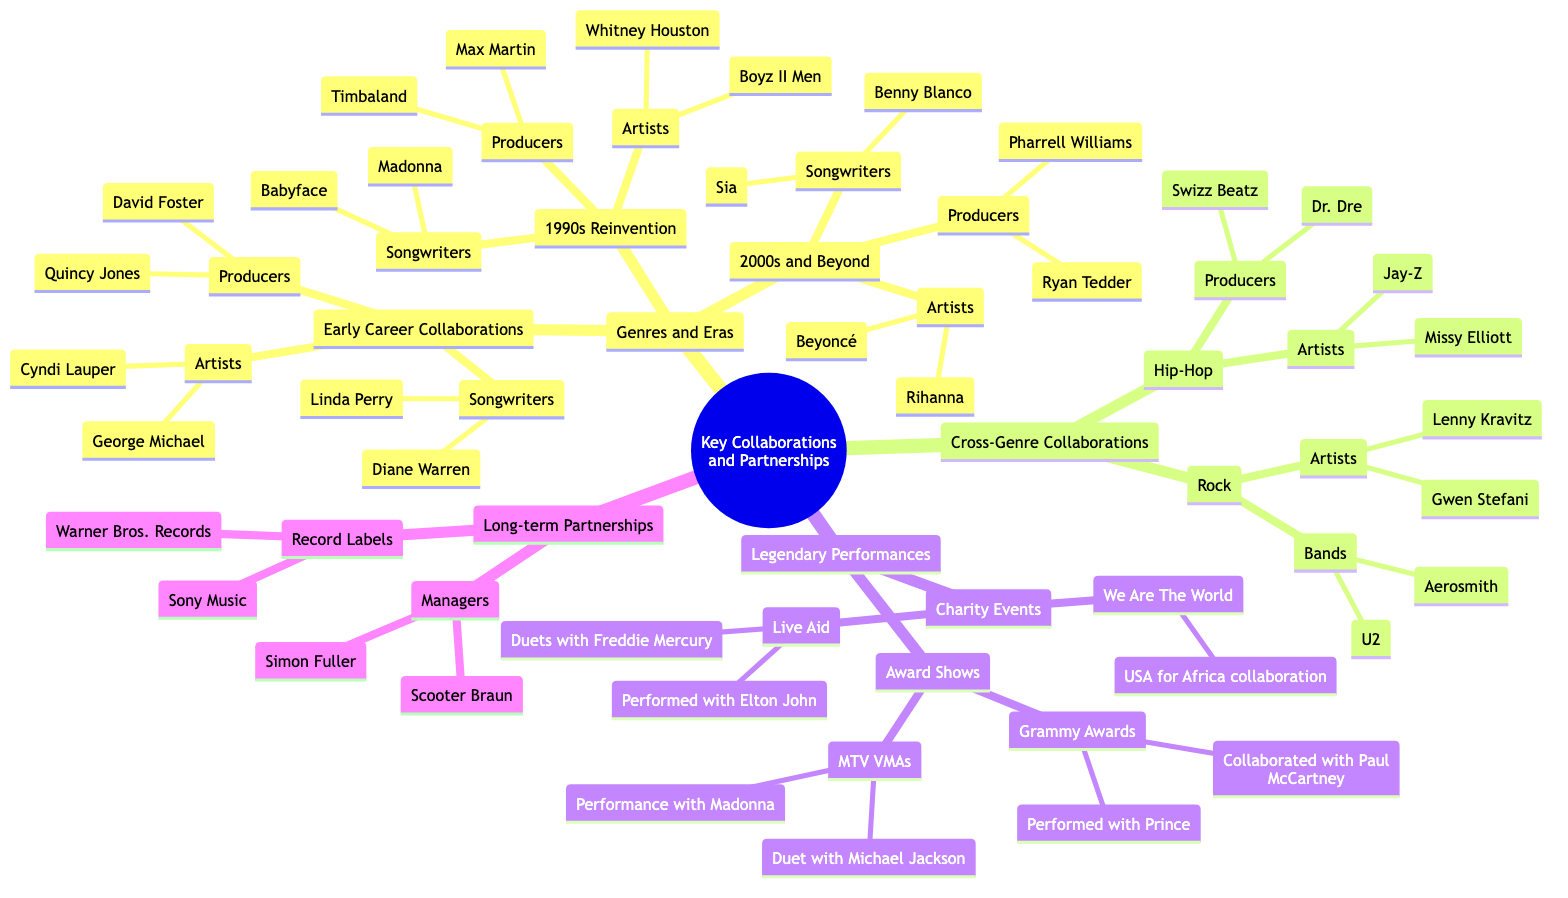What are the names of two producers from my early career collaborations? The diagram lists two producers under the "Early Career Collaborations" node: Quincy Jones and David Foster.
Answer: Quincy Jones, David Foster Who are the songwriters I collaborated with in the 1990s? The 1990s Reinvention section shows two songwriters: Babyface and Madonna.
Answer: Babyface, Madonna How many artists are listed under the "2000s and Beyond"? In the "2000s and Beyond" section, there are two artists mentioned: Beyoncé and Rihanna. Therefore, the total number of artists is two.
Answer: 2 Which event includes "USA for Africa collaboration"? The "We Are The World" node under "Legendary Performances" directs to the USA for Africa collaboration.
Answer: We Are The World What type of collaborations can be found in "Cross-Genre Collaborations"? The diagram indicates two categories under "Cross-Genre Collaborations": Hip-Hop and Rock.
Answer: Hip-Hop, Rock Which producers worked with me in Hip-Hop collaborations? The diagram identifies Dr. Dre and Swizz Beatz as the producers under the Hip-Hop node in Cross-Genre Collaborations.
Answer: Dr. Dre, Swizz Beatz Who performed with me at Live Aid? The Live Aid node indicates that I performed duets with Freddie Mercury and also performed with Elton John during the event.
Answer: Freddie Mercury, Elton John Which manager is mentioned under Long-term Partnerships? The Long-term Partnerships section lists two managers: Scooter Braun and Simon Fuller. Either name answers the question.
Answer: Scooter Braun (or Simon Fuller) What record label had a long-term partnership with me? The diagram shows two record labels, Warner Bros. Records and Sony Music, listed under Long-term Partnerships.
Answer: Warner Bros. Records (or Sony Music) 